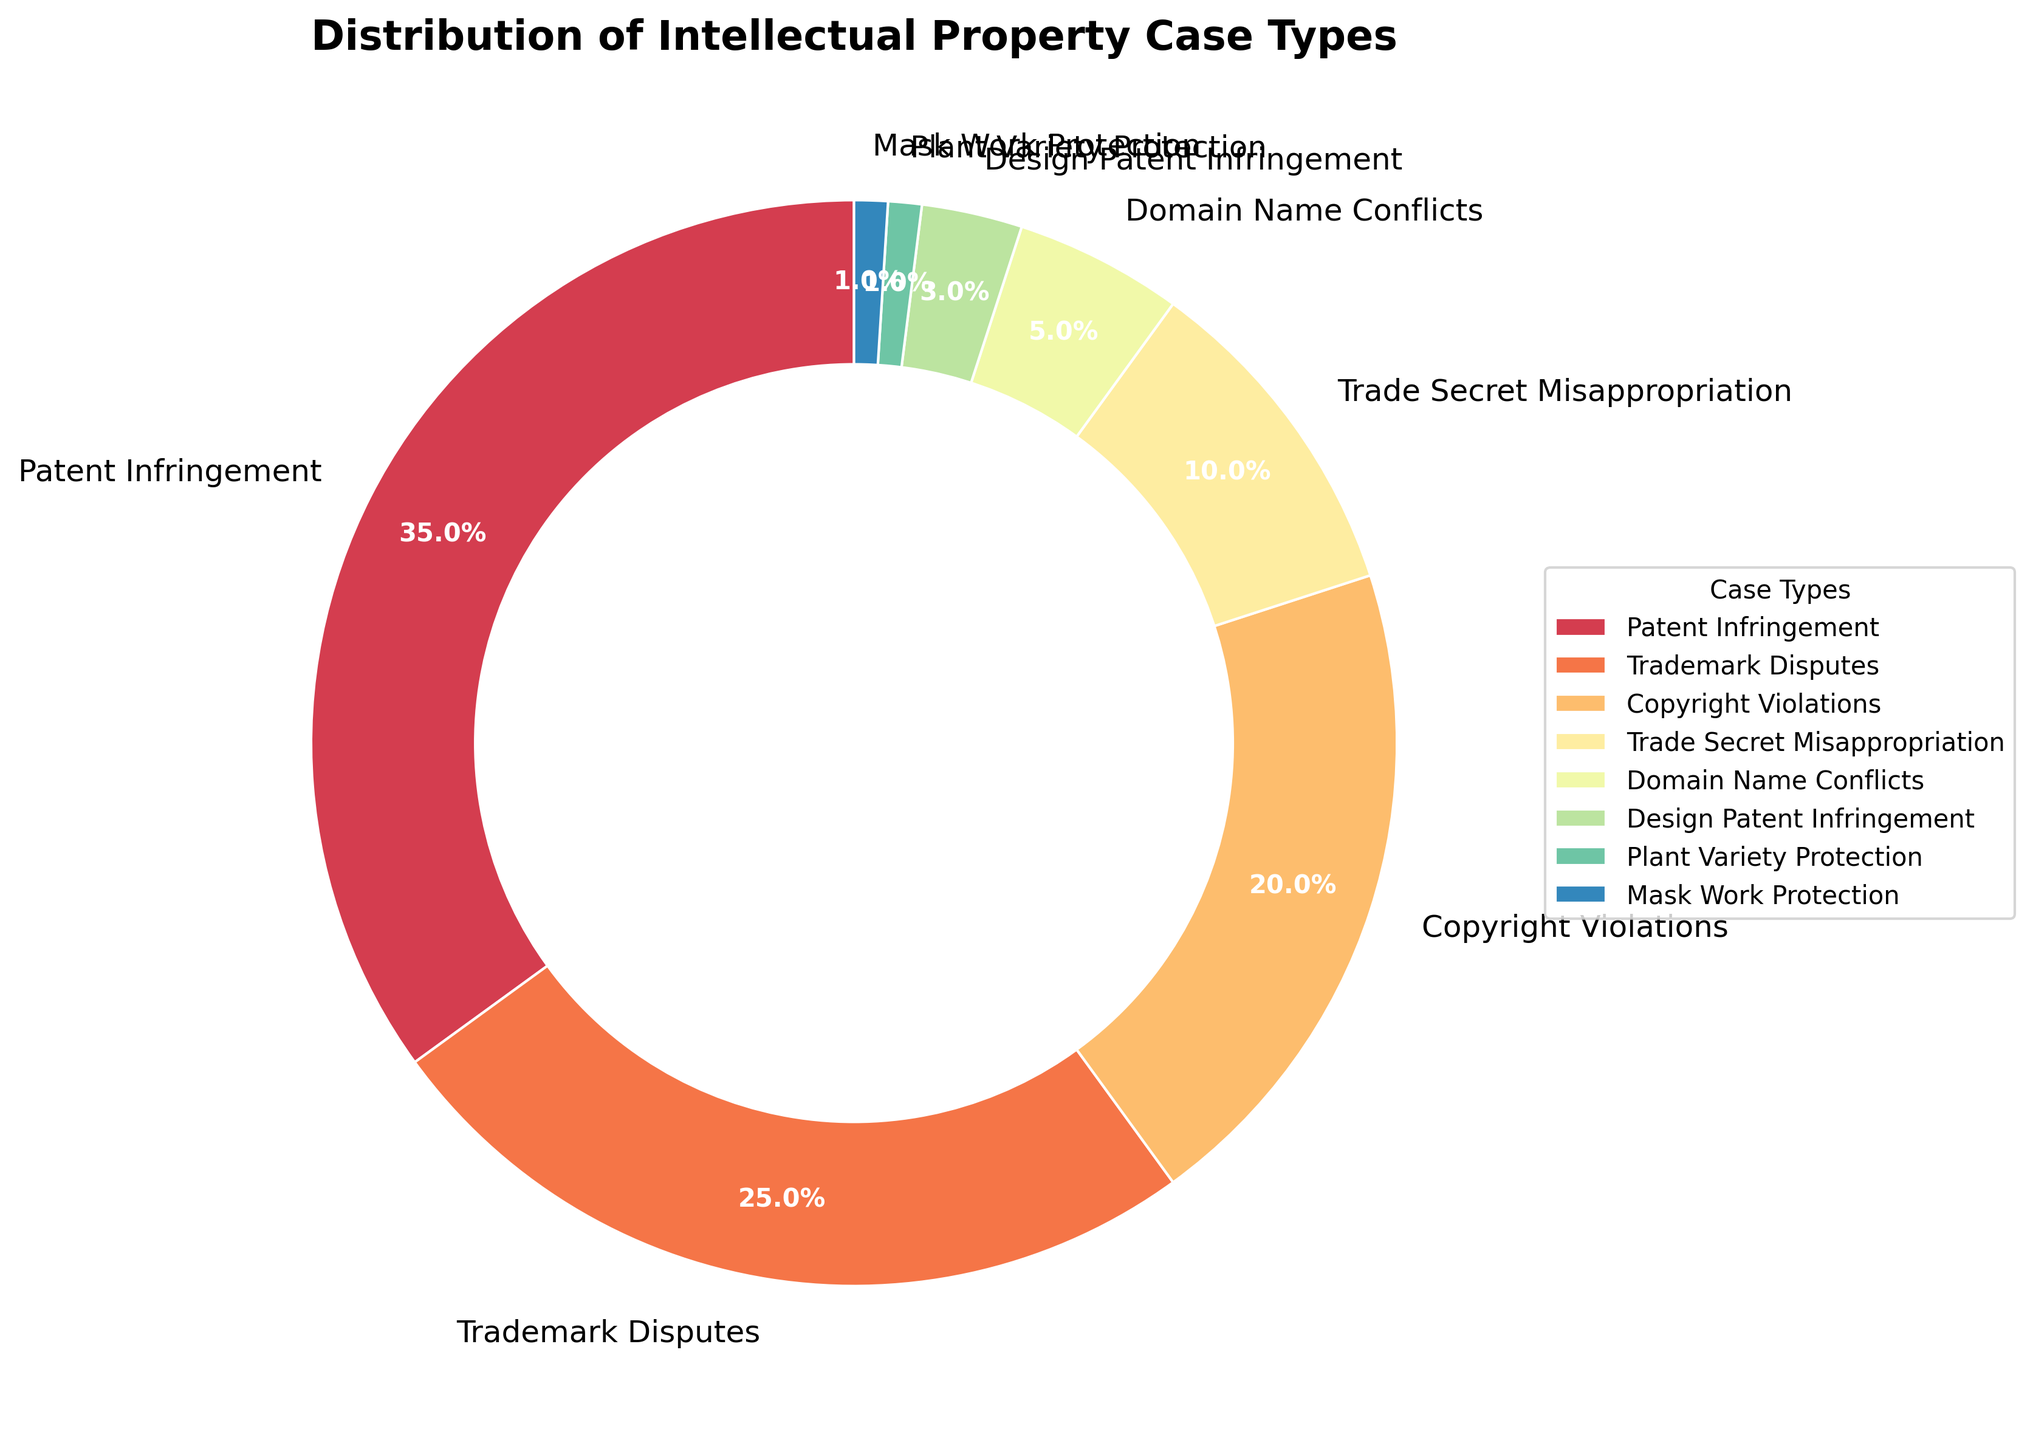What's the total percentage of cases handled that are related to patents (Patent Infringement and Design Patent Infringement)? Add the percentages of Patent Infringement and Design Patent Infringement: 35% + 3% = 38%
Answer: 38% Which case type has the second-highest percentage? From the pie chart, the case type with the highest percentage is Patent Infringement (35%), followed by Trademark Disputes (25%).
Answer: Trademark Disputes How much larger is the percentage of Patent Infringement cases than Copyright Violations? Subtract the percentage of Copyright Violations from Patent Infringement: 35% - 20% = 15%
Answer: 15% What is the combined percentage of the three least common case types? Add the percentages of Plant Variety Protection, Mask Work Protection, and Design Patent Infringement: 1% + 1% + 3% = 5%
Answer: 5% What's the difference in percentage between the most and the least common case types? Subtract the percentage of Mask Work Protection (the least common) from Patent Infringement (the most common): 35% - 1% = 34%
Answer: 34% Which case types have a percentage lower than 5%? The pie chart shows the case types with percentages less than 5% are Domain Name Conflicts, Design Patent Infringement, Plant Variety Protection, and Mask Work Protection.
Answer: Domain Name Conflicts, Design Patent Infringement, Plant Variety Protection, Mask Work Protection How much larger is the combined percentage of Copyright Violations and Trademark Disputes compared to Trade Secret Misappropriation? Add the percentages of Copyright Violations and Trademark Disputes: 20% + 25% = 45%. Then subtract the percentage of Trade Secret Misappropriation: 45% - 10% = 35%
Answer: 35% What is the order of case types from highest to lowest percentage? The order from highest to lowest is: Patent Infringement (35%), Trademark Disputes (25%), Copyright Violations (20%), Trade Secret Misappropriation (10%), Domain Name Conflicts (5%), Design Patent Infringement (3%), Plant Variety Protection (1%), Mask Work Protection (1%).
Answer: Patent Infringement, Trademark Disputes, Copyright Violations, Trade Secret Misappropriation, Domain Name Conflicts, Design Patent Infringement, Plant Variety Protection, Mask Work Protection Which colors represent the Domain Name Conflicts and Mask Work Protection? In the pie chart, the color representing Domain Name Conflicts is light purple, and the color representing Mask Work Protection is beige.
Answer: light purple and beige 